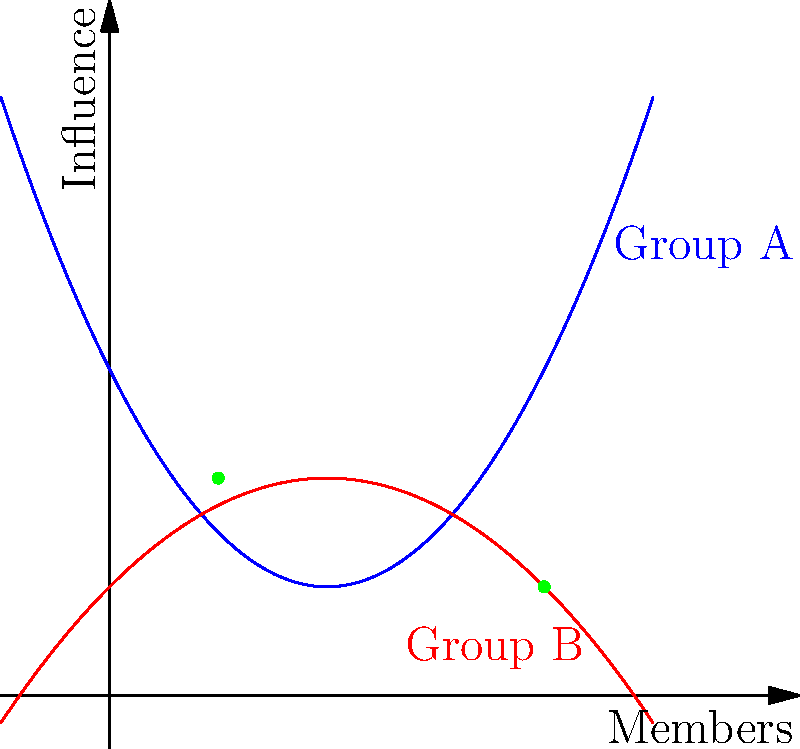In a study of two activist groups, their social network influence is modeled by the following functions:

Group A: $f(x) = 0.5x^2 - 2x + 3$
Group B: $g(x) = -0.25x^2 + x + 1$

Where $x$ represents the number of members, and $f(x)$ or $g(x)$ represents the group's influence.

Calculate the intersection points of these two social network graphs. What do these points represent in the context of grassroots movements? To find the intersection points, we need to solve the equation $f(x) = g(x)$:

1) Set up the equation:
   $0.5x^2 - 2x + 3 = -0.25x^2 + x + 1$

2) Rearrange to standard form:
   $0.75x^2 - 3x + 2 = 0$

3) Use the quadratic formula: $x = \frac{-b \pm \sqrt{b^2 - 4ac}}{2a}$
   Where $a = 0.75$, $b = -3$, and $c = 2$

4) Solve:
   $x = \frac{3 \pm \sqrt{9 - 4(0.75)(2)}}{2(0.75)}$
   $x = \frac{3 \pm \sqrt{9 - 6}}{1.5}$
   $x = \frac{3 \pm \sqrt{3}}{1.5}$

5) Simplify:
   $x_1 = \frac{3 + \sqrt{3}}{1.5} = 1 + \frac{\sqrt{3}}{3} \approx 1$
   $x_2 = \frac{3 - \sqrt{3}}{1.5} = 4 - \frac{\sqrt{3}}{3} \approx 4$

6) Find the corresponding y-values:
   For $x_1 \approx 1$: $f(1) = g(1) = 2$
   For $x_2 \approx 4$: $f(4) = g(4) = 1$

Therefore, the intersection points are approximately (1, 2) and (4, 1).

In the context of grassroots movements, these points represent:
1) When both groups have about 1 member, they have equal influence (2).
2) When both groups have about 4 members, they again have equal influence (1).

These intersections indicate moments of equal influence, which could be critical points for competition or collaboration between the activist groups.
Answer: (1, 2) and (4, 1); points of equal influence between groups 